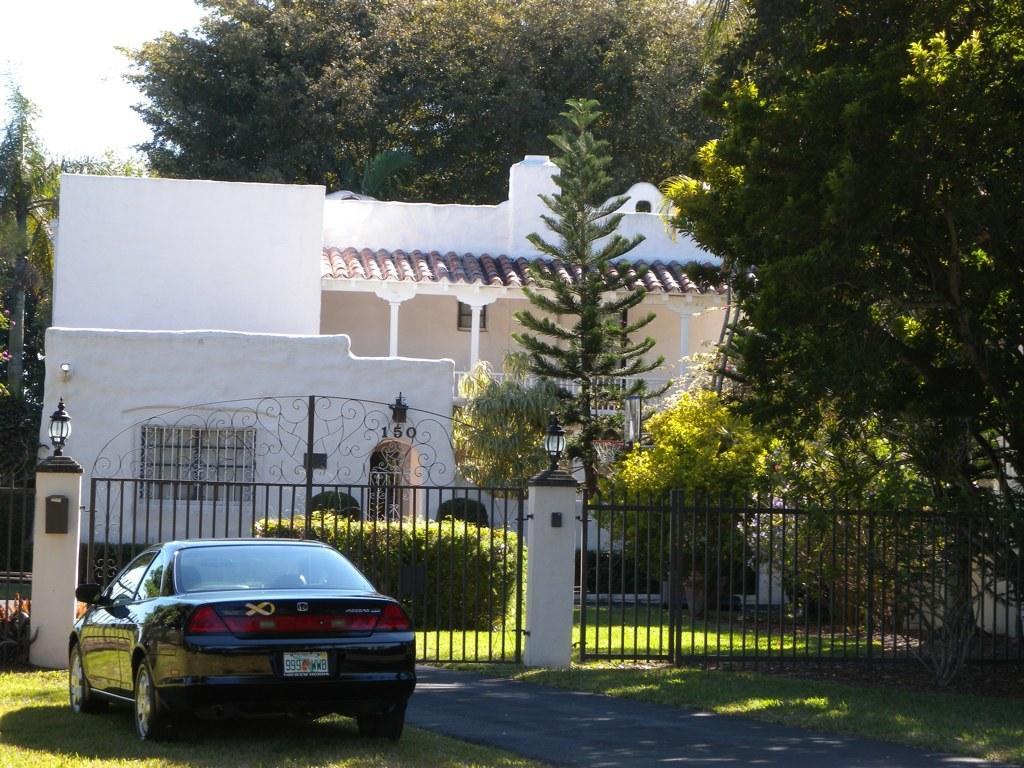Please provide a concise description of this image. There is car on the grass lawn on the left side. Near to that there is a gate with pillars. On the pillar there is light. Near to that there are railings. In the back there are trees and building with pillars and windows. In the background there are trees. There is a road in front of the gate. 